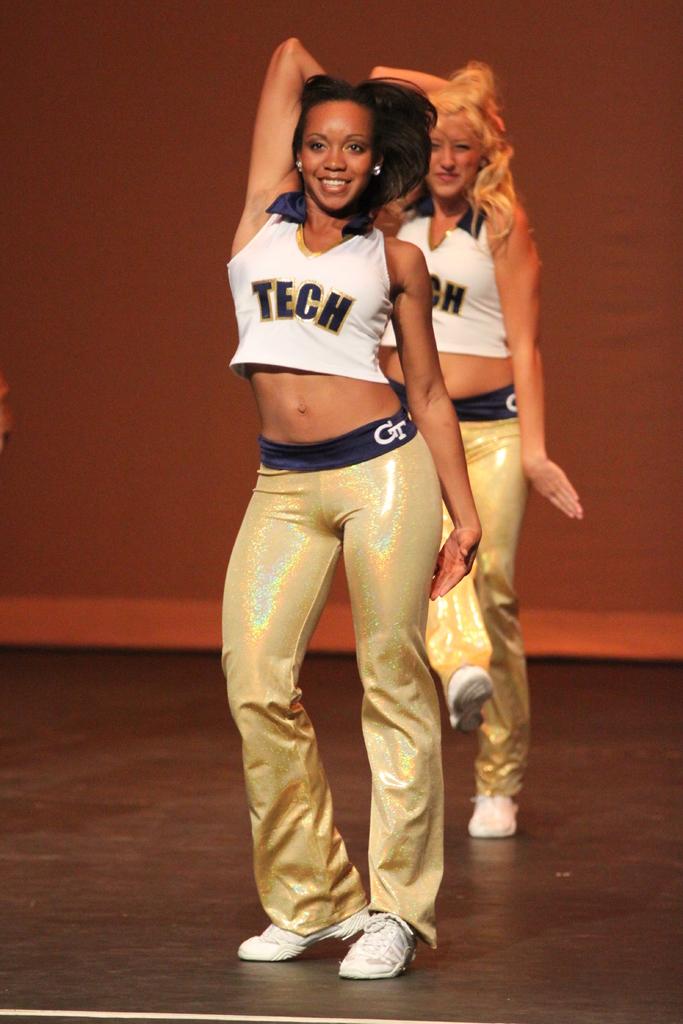Are they part of a team?
Offer a very short reply. Yes. What does the shirt say?
Offer a terse response. Tech. 